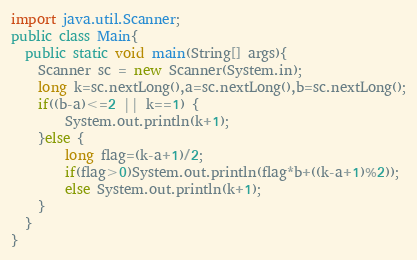<code> <loc_0><loc_0><loc_500><loc_500><_Java_>import java.util.Scanner;
public class Main{
  public static void main(String[] args){
    Scanner sc = new Scanner(System.in);
    long k=sc.nextLong(),a=sc.nextLong(),b=sc.nextLong();
    if((b-a)<=2 || k==1) {
    	System.out.println(k+1);
    }else {
    	long flag=(k-a+1)/2;
    	if(flag>0)System.out.println(flag*b+((k-a+1)%2));
    	else System.out.println(k+1);
    }
  }
}
</code> 